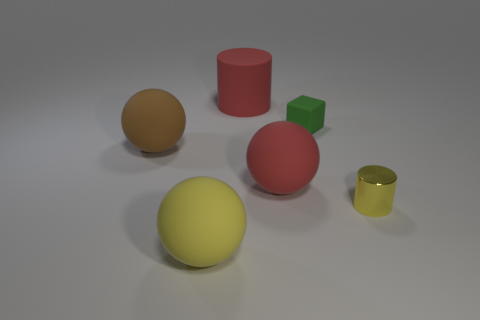Subtract all big yellow matte spheres. How many spheres are left? 2 Add 4 tiny cylinders. How many objects exist? 10 Subtract all cylinders. How many objects are left? 4 Subtract 1 spheres. How many spheres are left? 2 Add 6 small yellow rubber blocks. How many small yellow rubber blocks exist? 6 Subtract all red balls. How many balls are left? 2 Subtract 0 blue balls. How many objects are left? 6 Subtract all yellow cylinders. Subtract all red balls. How many cylinders are left? 1 Subtract all large rubber things. Subtract all large red rubber cubes. How many objects are left? 2 Add 3 big matte spheres. How many big matte spheres are left? 6 